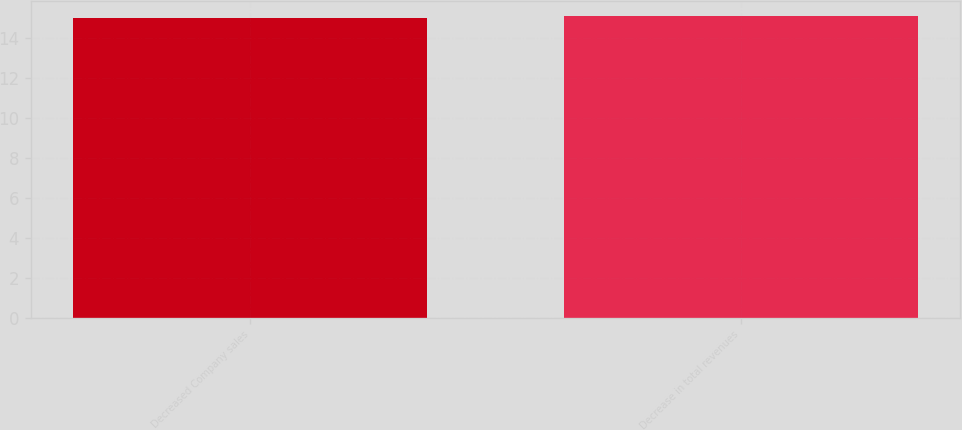Convert chart to OTSL. <chart><loc_0><loc_0><loc_500><loc_500><bar_chart><fcel>Decreased Company sales<fcel>Decrease in total revenues<nl><fcel>15<fcel>15.1<nl></chart> 